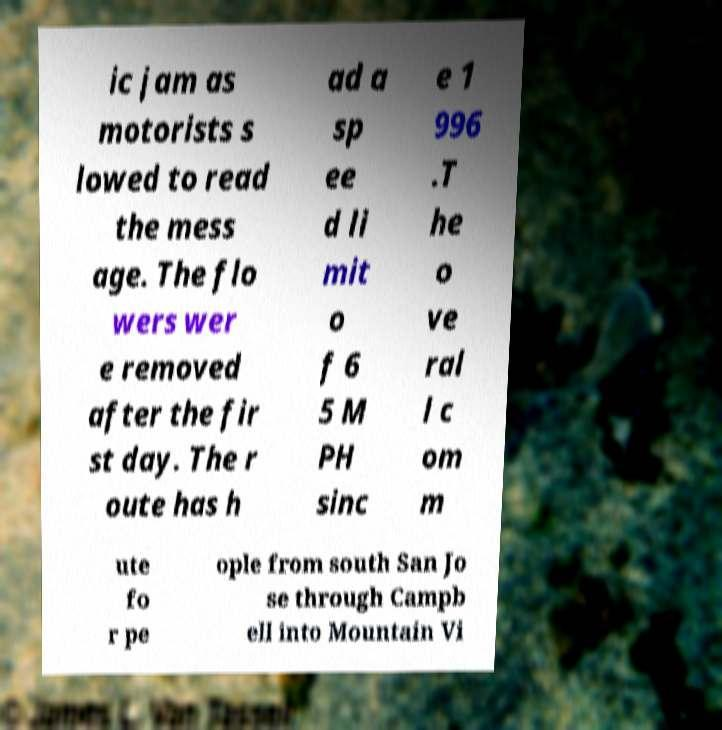I need the written content from this picture converted into text. Can you do that? ic jam as motorists s lowed to read the mess age. The flo wers wer e removed after the fir st day. The r oute has h ad a sp ee d li mit o f 6 5 M PH sinc e 1 996 .T he o ve ral l c om m ute fo r pe ople from south San Jo se through Campb ell into Mountain Vi 